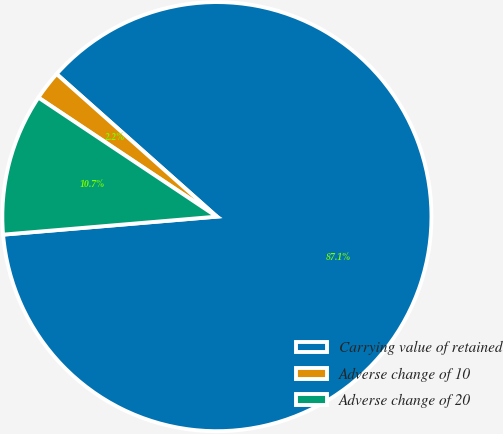Convert chart. <chart><loc_0><loc_0><loc_500><loc_500><pie_chart><fcel>Carrying value of retained<fcel>Adverse change of 10<fcel>Adverse change of 20<nl><fcel>87.09%<fcel>2.21%<fcel>10.7%<nl></chart> 